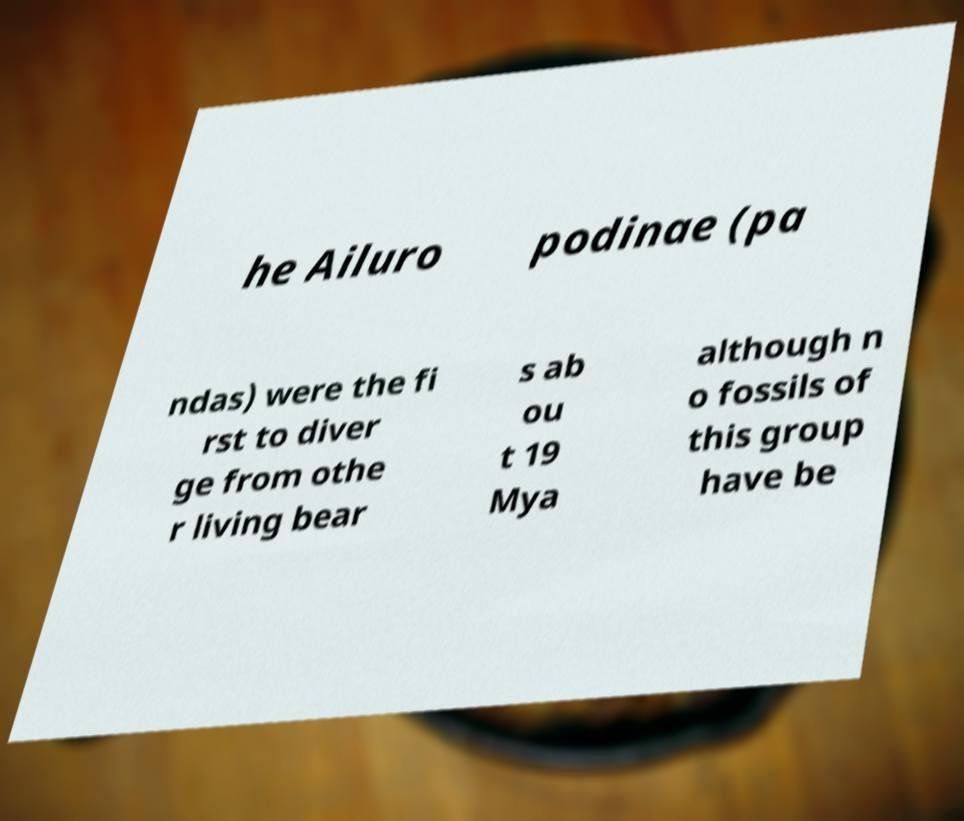Please identify and transcribe the text found in this image. he Ailuro podinae (pa ndas) were the fi rst to diver ge from othe r living bear s ab ou t 19 Mya although n o fossils of this group have be 